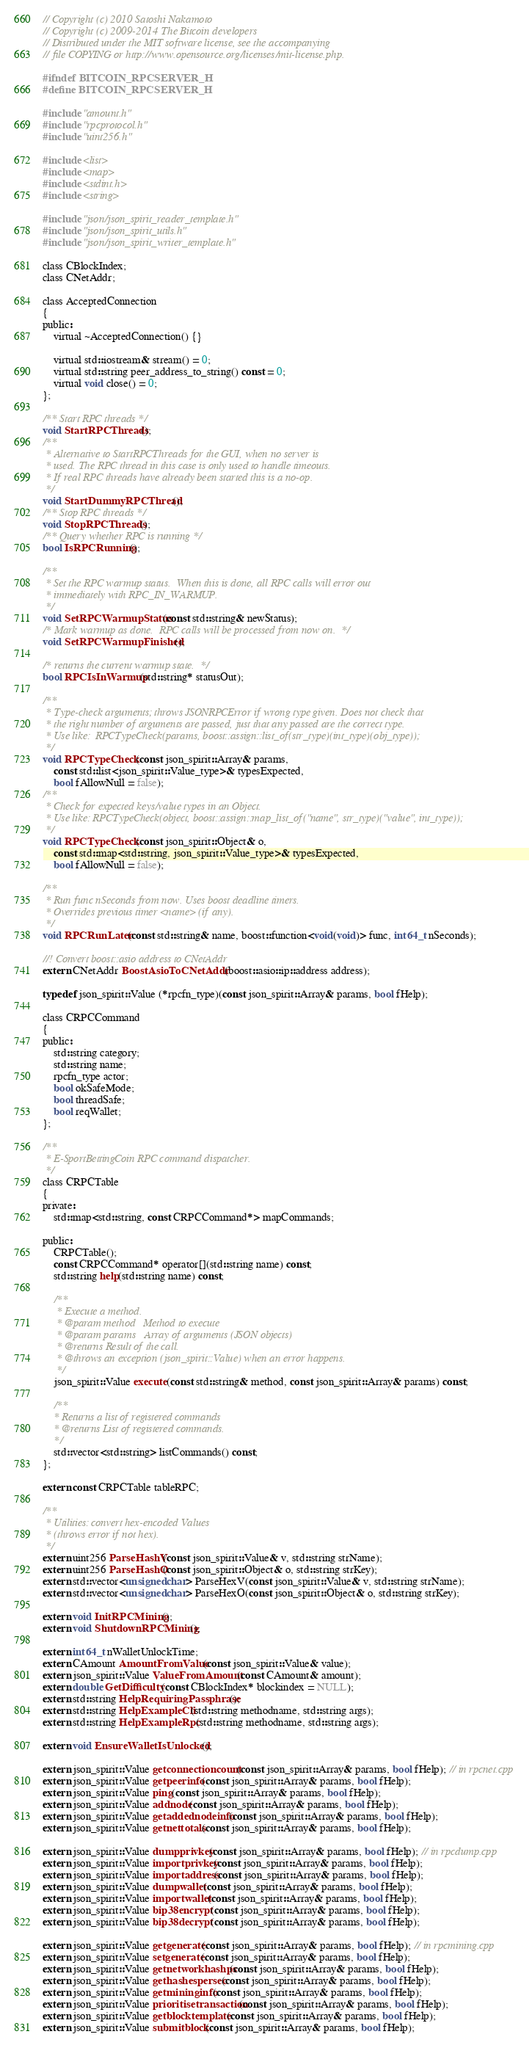Convert code to text. <code><loc_0><loc_0><loc_500><loc_500><_C_>// Copyright (c) 2010 Satoshi Nakamoto
// Copyright (c) 2009-2014 The Bitcoin developers
// Distributed under the MIT software license, see the accompanying
// file COPYING or http://www.opensource.org/licenses/mit-license.php.

#ifndef BITCOIN_RPCSERVER_H
#define BITCOIN_RPCSERVER_H

#include "amount.h"
#include "rpcprotocol.h"
#include "uint256.h"

#include <list>
#include <map>
#include <stdint.h>
#include <string>

#include "json/json_spirit_reader_template.h"
#include "json/json_spirit_utils.h"
#include "json/json_spirit_writer_template.h"

class CBlockIndex;
class CNetAddr;

class AcceptedConnection
{
public:
    virtual ~AcceptedConnection() {}

    virtual std::iostream& stream() = 0;
    virtual std::string peer_address_to_string() const = 0;
    virtual void close() = 0;
};

/** Start RPC threads */
void StartRPCThreads();
/**
 * Alternative to StartRPCThreads for the GUI, when no server is
 * used. The RPC thread in this case is only used to handle timeouts.
 * If real RPC threads have already been started this is a no-op.
 */
void StartDummyRPCThread();
/** Stop RPC threads */
void StopRPCThreads();
/** Query whether RPC is running */
bool IsRPCRunning();

/**
 * Set the RPC warmup status.  When this is done, all RPC calls will error out
 * immediately with RPC_IN_WARMUP.
 */
void SetRPCWarmupStatus(const std::string& newStatus);
/* Mark warmup as done.  RPC calls will be processed from now on.  */
void SetRPCWarmupFinished();

/* returns the current warmup state.  */
bool RPCIsInWarmup(std::string* statusOut);

/**
 * Type-check arguments; throws JSONRPCError if wrong type given. Does not check that
 * the right number of arguments are passed, just that any passed are the correct type.
 * Use like:  RPCTypeCheck(params, boost::assign::list_of(str_type)(int_type)(obj_type));
 */
void RPCTypeCheck(const json_spirit::Array& params,
    const std::list<json_spirit::Value_type>& typesExpected,
    bool fAllowNull = false);
/**
 * Check for expected keys/value types in an Object.
 * Use like: RPCTypeCheck(object, boost::assign::map_list_of("name", str_type)("value", int_type));
 */
void RPCTypeCheck(const json_spirit::Object& o,
    const std::map<std::string, json_spirit::Value_type>& typesExpected,
    bool fAllowNull = false);

/**
 * Run func nSeconds from now. Uses boost deadline timers.
 * Overrides previous timer <name> (if any).
 */
void RPCRunLater(const std::string& name, boost::function<void(void)> func, int64_t nSeconds);

//! Convert boost::asio address to CNetAddr
extern CNetAddr BoostAsioToCNetAddr(boost::asio::ip::address address);

typedef json_spirit::Value (*rpcfn_type)(const json_spirit::Array& params, bool fHelp);

class CRPCCommand
{
public:
    std::string category;
    std::string name;
    rpcfn_type actor;
    bool okSafeMode;
    bool threadSafe;
    bool reqWallet;
};

/**
 * E-SportBettingCoin RPC command dispatcher.
 */
class CRPCTable
{
private:
    std::map<std::string, const CRPCCommand*> mapCommands;

public:
    CRPCTable();
    const CRPCCommand* operator[](std::string name) const;
    std::string help(std::string name) const;

    /**
     * Execute a method.
     * @param method   Method to execute
     * @param params   Array of arguments (JSON objects)
     * @returns Result of the call.
     * @throws an exception (json_spirit::Value) when an error happens.
     */
    json_spirit::Value execute(const std::string& method, const json_spirit::Array& params) const;

    /**
    * Returns a list of registered commands
    * @returns List of registered commands.
    */
    std::vector<std::string> listCommands() const;
};

extern const CRPCTable tableRPC;

/**
 * Utilities: convert hex-encoded Values
 * (throws error if not hex).
 */
extern uint256 ParseHashV(const json_spirit::Value& v, std::string strName);
extern uint256 ParseHashO(const json_spirit::Object& o, std::string strKey);
extern std::vector<unsigned char> ParseHexV(const json_spirit::Value& v, std::string strName);
extern std::vector<unsigned char> ParseHexO(const json_spirit::Object& o, std::string strKey);

extern void InitRPCMining();
extern void ShutdownRPCMining();

extern int64_t nWalletUnlockTime;
extern CAmount AmountFromValue(const json_spirit::Value& value);
extern json_spirit::Value ValueFromAmount(const CAmount& amount);
extern double GetDifficulty(const CBlockIndex* blockindex = NULL);
extern std::string HelpRequiringPassphrase();
extern std::string HelpExampleCli(std::string methodname, std::string args);
extern std::string HelpExampleRpc(std::string methodname, std::string args);

extern void EnsureWalletIsUnlocked();

extern json_spirit::Value getconnectioncount(const json_spirit::Array& params, bool fHelp); // in rpcnet.cpp
extern json_spirit::Value getpeerinfo(const json_spirit::Array& params, bool fHelp);
extern json_spirit::Value ping(const json_spirit::Array& params, bool fHelp);
extern json_spirit::Value addnode(const json_spirit::Array& params, bool fHelp);
extern json_spirit::Value getaddednodeinfo(const json_spirit::Array& params, bool fHelp);
extern json_spirit::Value getnettotals(const json_spirit::Array& params, bool fHelp);

extern json_spirit::Value dumpprivkey(const json_spirit::Array& params, bool fHelp); // in rpcdump.cpp
extern json_spirit::Value importprivkey(const json_spirit::Array& params, bool fHelp);
extern json_spirit::Value importaddress(const json_spirit::Array& params, bool fHelp);
extern json_spirit::Value dumpwallet(const json_spirit::Array& params, bool fHelp);
extern json_spirit::Value importwallet(const json_spirit::Array& params, bool fHelp);
extern json_spirit::Value bip38encrypt(const json_spirit::Array& params, bool fHelp);
extern json_spirit::Value bip38decrypt(const json_spirit::Array& params, bool fHelp);

extern json_spirit::Value getgenerate(const json_spirit::Array& params, bool fHelp); // in rpcmining.cpp
extern json_spirit::Value setgenerate(const json_spirit::Array& params, bool fHelp);
extern json_spirit::Value getnetworkhashps(const json_spirit::Array& params, bool fHelp);
extern json_spirit::Value gethashespersec(const json_spirit::Array& params, bool fHelp);
extern json_spirit::Value getmininginfo(const json_spirit::Array& params, bool fHelp);
extern json_spirit::Value prioritisetransaction(const json_spirit::Array& params, bool fHelp);
extern json_spirit::Value getblocktemplate(const json_spirit::Array& params, bool fHelp);
extern json_spirit::Value submitblock(const json_spirit::Array& params, bool fHelp);</code> 